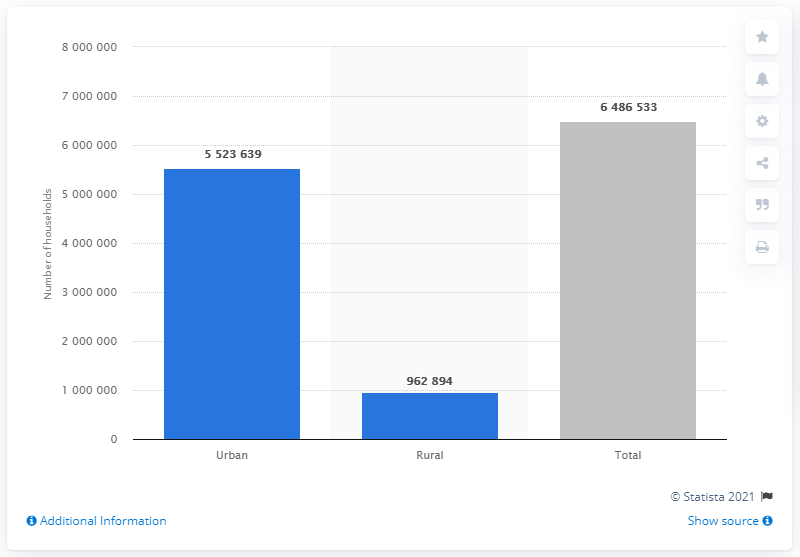How many of Chile's 6.5 million households are located in urban areas?
 5523639 